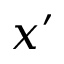<formula> <loc_0><loc_0><loc_500><loc_500>x ^ { \prime }</formula> 